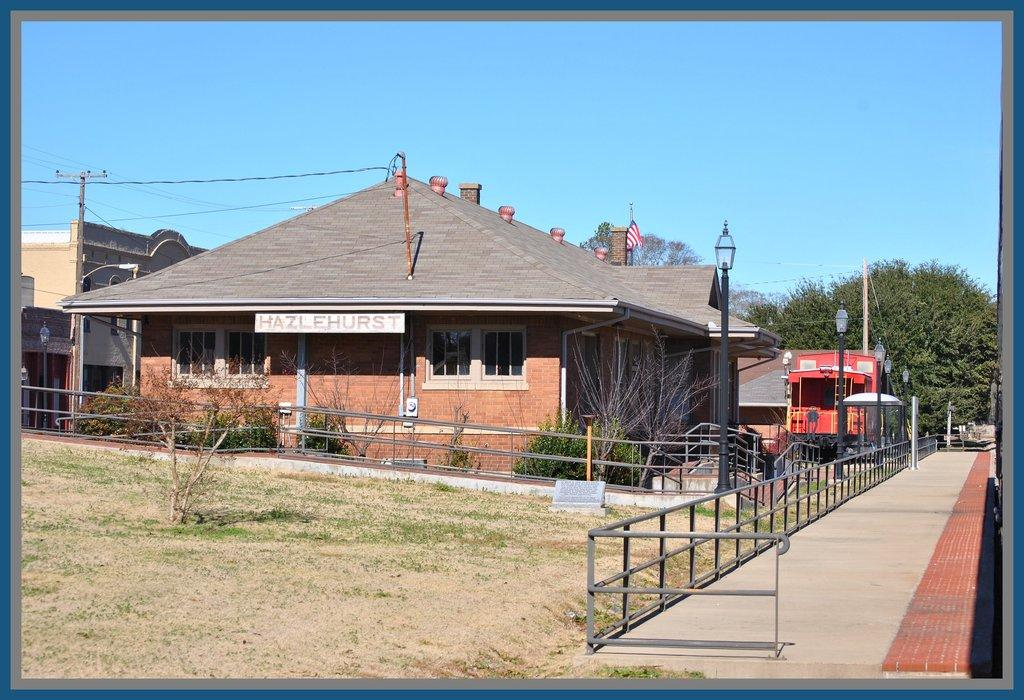What type of structure is in the image? There is a house in the image. What is in front of the house? There is a fence in front of the house. What can be seen illuminated in the image? Lights are visible in the image. What type of vegetation is present in the image? Trees and plants are visible in the image. What are the vertical structures supporting the power line cables? Poles are visible in the image. What is visible at the top of the image? The sky is visible at the top of the image. Where is the coast visible in the image? There is no coast visible in the image. What type of organ is present in the image? There are no organs present in the image. 